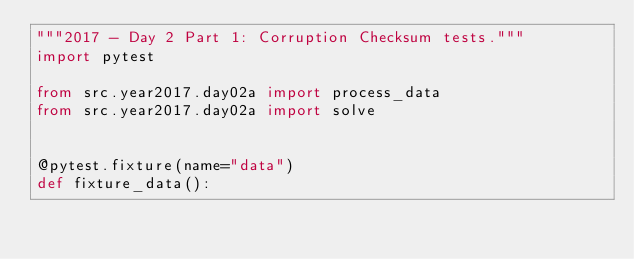Convert code to text. <code><loc_0><loc_0><loc_500><loc_500><_Python_>"""2017 - Day 2 Part 1: Corruption Checksum tests."""
import pytest

from src.year2017.day02a import process_data
from src.year2017.day02a import solve


@pytest.fixture(name="data")
def fixture_data():</code> 